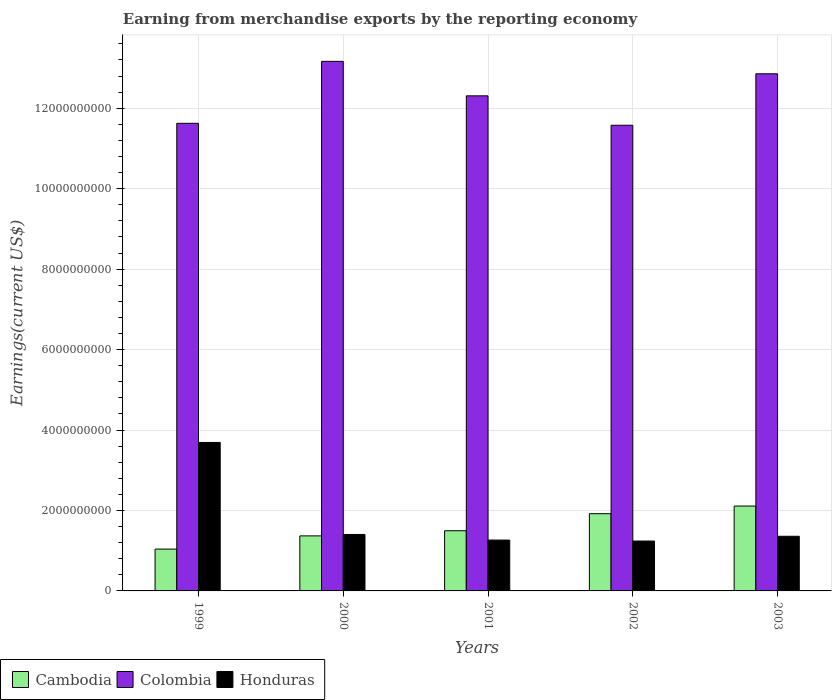Are the number of bars per tick equal to the number of legend labels?
Keep it short and to the point. Yes. How many bars are there on the 5th tick from the left?
Your answer should be very brief. 3. What is the label of the 1st group of bars from the left?
Your response must be concise. 1999. What is the amount earned from merchandise exports in Cambodia in 2001?
Offer a very short reply. 1.50e+09. Across all years, what is the maximum amount earned from merchandise exports in Colombia?
Make the answer very short. 1.32e+1. Across all years, what is the minimum amount earned from merchandise exports in Colombia?
Offer a very short reply. 1.16e+1. In which year was the amount earned from merchandise exports in Colombia maximum?
Offer a terse response. 2000. In which year was the amount earned from merchandise exports in Honduras minimum?
Ensure brevity in your answer.  2002. What is the total amount earned from merchandise exports in Honduras in the graph?
Give a very brief answer. 8.96e+09. What is the difference between the amount earned from merchandise exports in Colombia in 2000 and that in 2002?
Keep it short and to the point. 1.59e+09. What is the difference between the amount earned from merchandise exports in Colombia in 2000 and the amount earned from merchandise exports in Cambodia in 2001?
Offer a terse response. 1.17e+1. What is the average amount earned from merchandise exports in Cambodia per year?
Keep it short and to the point. 1.59e+09. In the year 2000, what is the difference between the amount earned from merchandise exports in Cambodia and amount earned from merchandise exports in Honduras?
Provide a short and direct response. -3.54e+07. What is the ratio of the amount earned from merchandise exports in Colombia in 2002 to that in 2003?
Provide a succinct answer. 0.9. Is the difference between the amount earned from merchandise exports in Cambodia in 2000 and 2003 greater than the difference between the amount earned from merchandise exports in Honduras in 2000 and 2003?
Ensure brevity in your answer.  No. What is the difference between the highest and the second highest amount earned from merchandise exports in Cambodia?
Provide a succinct answer. 1.90e+08. What is the difference between the highest and the lowest amount earned from merchandise exports in Honduras?
Give a very brief answer. 2.45e+09. What does the 3rd bar from the left in 2003 represents?
Your answer should be very brief. Honduras. What does the 1st bar from the right in 1999 represents?
Your answer should be compact. Honduras. Is it the case that in every year, the sum of the amount earned from merchandise exports in Colombia and amount earned from merchandise exports in Honduras is greater than the amount earned from merchandise exports in Cambodia?
Your response must be concise. Yes. Are all the bars in the graph horizontal?
Make the answer very short. No. What is the difference between two consecutive major ticks on the Y-axis?
Your response must be concise. 2.00e+09. Does the graph contain any zero values?
Ensure brevity in your answer.  No. What is the title of the graph?
Offer a terse response. Earning from merchandise exports by the reporting economy. Does "Sub-Saharan Africa (all income levels)" appear as one of the legend labels in the graph?
Your response must be concise. No. What is the label or title of the Y-axis?
Provide a short and direct response. Earnings(current US$). What is the Earnings(current US$) of Cambodia in 1999?
Your answer should be compact. 1.04e+09. What is the Earnings(current US$) of Colombia in 1999?
Make the answer very short. 1.16e+1. What is the Earnings(current US$) in Honduras in 1999?
Provide a succinct answer. 3.69e+09. What is the Earnings(current US$) of Cambodia in 2000?
Your response must be concise. 1.37e+09. What is the Earnings(current US$) of Colombia in 2000?
Make the answer very short. 1.32e+1. What is the Earnings(current US$) in Honduras in 2000?
Ensure brevity in your answer.  1.40e+09. What is the Earnings(current US$) of Cambodia in 2001?
Keep it short and to the point. 1.50e+09. What is the Earnings(current US$) in Colombia in 2001?
Your answer should be very brief. 1.23e+1. What is the Earnings(current US$) in Honduras in 2001?
Your answer should be very brief. 1.26e+09. What is the Earnings(current US$) of Cambodia in 2002?
Offer a very short reply. 1.92e+09. What is the Earnings(current US$) of Colombia in 2002?
Your response must be concise. 1.16e+1. What is the Earnings(current US$) in Honduras in 2002?
Your response must be concise. 1.24e+09. What is the Earnings(current US$) in Cambodia in 2003?
Your answer should be very brief. 2.11e+09. What is the Earnings(current US$) in Colombia in 2003?
Ensure brevity in your answer.  1.29e+1. What is the Earnings(current US$) of Honduras in 2003?
Offer a very short reply. 1.36e+09. Across all years, what is the maximum Earnings(current US$) of Cambodia?
Your answer should be very brief. 2.11e+09. Across all years, what is the maximum Earnings(current US$) of Colombia?
Your answer should be very brief. 1.32e+1. Across all years, what is the maximum Earnings(current US$) of Honduras?
Keep it short and to the point. 3.69e+09. Across all years, what is the minimum Earnings(current US$) in Cambodia?
Ensure brevity in your answer.  1.04e+09. Across all years, what is the minimum Earnings(current US$) in Colombia?
Provide a succinct answer. 1.16e+1. Across all years, what is the minimum Earnings(current US$) in Honduras?
Keep it short and to the point. 1.24e+09. What is the total Earnings(current US$) in Cambodia in the graph?
Provide a succinct answer. 7.93e+09. What is the total Earnings(current US$) in Colombia in the graph?
Your answer should be very brief. 6.15e+1. What is the total Earnings(current US$) of Honduras in the graph?
Give a very brief answer. 8.96e+09. What is the difference between the Earnings(current US$) of Cambodia in 1999 and that in 2000?
Offer a very short reply. -3.28e+08. What is the difference between the Earnings(current US$) of Colombia in 1999 and that in 2000?
Ensure brevity in your answer.  -1.54e+09. What is the difference between the Earnings(current US$) in Honduras in 1999 and that in 2000?
Provide a succinct answer. 2.29e+09. What is the difference between the Earnings(current US$) of Cambodia in 1999 and that in 2001?
Your response must be concise. -4.56e+08. What is the difference between the Earnings(current US$) of Colombia in 1999 and that in 2001?
Your answer should be compact. -6.83e+08. What is the difference between the Earnings(current US$) in Honduras in 1999 and that in 2001?
Offer a terse response. 2.43e+09. What is the difference between the Earnings(current US$) in Cambodia in 1999 and that in 2002?
Ensure brevity in your answer.  -8.79e+08. What is the difference between the Earnings(current US$) of Colombia in 1999 and that in 2002?
Provide a short and direct response. 4.76e+07. What is the difference between the Earnings(current US$) of Honduras in 1999 and that in 2002?
Make the answer very short. 2.45e+09. What is the difference between the Earnings(current US$) in Cambodia in 1999 and that in 2003?
Ensure brevity in your answer.  -1.07e+09. What is the difference between the Earnings(current US$) of Colombia in 1999 and that in 2003?
Provide a succinct answer. -1.23e+09. What is the difference between the Earnings(current US$) of Honduras in 1999 and that in 2003?
Your answer should be very brief. 2.33e+09. What is the difference between the Earnings(current US$) of Cambodia in 2000 and that in 2001?
Provide a succinct answer. -1.28e+08. What is the difference between the Earnings(current US$) in Colombia in 2000 and that in 2001?
Keep it short and to the point. 8.57e+08. What is the difference between the Earnings(current US$) of Honduras in 2000 and that in 2001?
Offer a very short reply. 1.40e+08. What is the difference between the Earnings(current US$) of Cambodia in 2000 and that in 2002?
Your answer should be compact. -5.51e+08. What is the difference between the Earnings(current US$) of Colombia in 2000 and that in 2002?
Offer a very short reply. 1.59e+09. What is the difference between the Earnings(current US$) in Honduras in 2000 and that in 2002?
Your response must be concise. 1.64e+08. What is the difference between the Earnings(current US$) in Cambodia in 2000 and that in 2003?
Your answer should be very brief. -7.42e+08. What is the difference between the Earnings(current US$) in Colombia in 2000 and that in 2003?
Your answer should be very brief. 3.09e+08. What is the difference between the Earnings(current US$) in Honduras in 2000 and that in 2003?
Provide a short and direct response. 4.49e+07. What is the difference between the Earnings(current US$) of Cambodia in 2001 and that in 2002?
Ensure brevity in your answer.  -4.23e+08. What is the difference between the Earnings(current US$) of Colombia in 2001 and that in 2002?
Your response must be concise. 7.31e+08. What is the difference between the Earnings(current US$) in Honduras in 2001 and that in 2002?
Your answer should be compact. 2.41e+07. What is the difference between the Earnings(current US$) of Cambodia in 2001 and that in 2003?
Provide a short and direct response. -6.14e+08. What is the difference between the Earnings(current US$) in Colombia in 2001 and that in 2003?
Provide a short and direct response. -5.48e+08. What is the difference between the Earnings(current US$) in Honduras in 2001 and that in 2003?
Ensure brevity in your answer.  -9.46e+07. What is the difference between the Earnings(current US$) in Cambodia in 2002 and that in 2003?
Your answer should be compact. -1.90e+08. What is the difference between the Earnings(current US$) of Colombia in 2002 and that in 2003?
Your response must be concise. -1.28e+09. What is the difference between the Earnings(current US$) of Honduras in 2002 and that in 2003?
Offer a very short reply. -1.19e+08. What is the difference between the Earnings(current US$) of Cambodia in 1999 and the Earnings(current US$) of Colombia in 2000?
Ensure brevity in your answer.  -1.21e+1. What is the difference between the Earnings(current US$) of Cambodia in 1999 and the Earnings(current US$) of Honduras in 2000?
Make the answer very short. -3.63e+08. What is the difference between the Earnings(current US$) of Colombia in 1999 and the Earnings(current US$) of Honduras in 2000?
Offer a terse response. 1.02e+1. What is the difference between the Earnings(current US$) in Cambodia in 1999 and the Earnings(current US$) in Colombia in 2001?
Your answer should be very brief. -1.13e+1. What is the difference between the Earnings(current US$) in Cambodia in 1999 and the Earnings(current US$) in Honduras in 2001?
Make the answer very short. -2.24e+08. What is the difference between the Earnings(current US$) of Colombia in 1999 and the Earnings(current US$) of Honduras in 2001?
Offer a very short reply. 1.04e+1. What is the difference between the Earnings(current US$) in Cambodia in 1999 and the Earnings(current US$) in Colombia in 2002?
Keep it short and to the point. -1.05e+1. What is the difference between the Earnings(current US$) of Cambodia in 1999 and the Earnings(current US$) of Honduras in 2002?
Keep it short and to the point. -2.00e+08. What is the difference between the Earnings(current US$) in Colombia in 1999 and the Earnings(current US$) in Honduras in 2002?
Your response must be concise. 1.04e+1. What is the difference between the Earnings(current US$) in Cambodia in 1999 and the Earnings(current US$) in Colombia in 2003?
Your answer should be compact. -1.18e+1. What is the difference between the Earnings(current US$) in Cambodia in 1999 and the Earnings(current US$) in Honduras in 2003?
Provide a succinct answer. -3.19e+08. What is the difference between the Earnings(current US$) in Colombia in 1999 and the Earnings(current US$) in Honduras in 2003?
Give a very brief answer. 1.03e+1. What is the difference between the Earnings(current US$) in Cambodia in 2000 and the Earnings(current US$) in Colombia in 2001?
Make the answer very short. -1.09e+1. What is the difference between the Earnings(current US$) of Cambodia in 2000 and the Earnings(current US$) of Honduras in 2001?
Provide a short and direct response. 1.04e+08. What is the difference between the Earnings(current US$) in Colombia in 2000 and the Earnings(current US$) in Honduras in 2001?
Give a very brief answer. 1.19e+1. What is the difference between the Earnings(current US$) in Cambodia in 2000 and the Earnings(current US$) in Colombia in 2002?
Ensure brevity in your answer.  -1.02e+1. What is the difference between the Earnings(current US$) of Cambodia in 2000 and the Earnings(current US$) of Honduras in 2002?
Offer a very short reply. 1.28e+08. What is the difference between the Earnings(current US$) of Colombia in 2000 and the Earnings(current US$) of Honduras in 2002?
Offer a terse response. 1.19e+1. What is the difference between the Earnings(current US$) in Cambodia in 2000 and the Earnings(current US$) in Colombia in 2003?
Your answer should be compact. -1.15e+1. What is the difference between the Earnings(current US$) in Cambodia in 2000 and the Earnings(current US$) in Honduras in 2003?
Provide a succinct answer. 9.48e+06. What is the difference between the Earnings(current US$) in Colombia in 2000 and the Earnings(current US$) in Honduras in 2003?
Give a very brief answer. 1.18e+1. What is the difference between the Earnings(current US$) in Cambodia in 2001 and the Earnings(current US$) in Colombia in 2002?
Make the answer very short. -1.01e+1. What is the difference between the Earnings(current US$) in Cambodia in 2001 and the Earnings(current US$) in Honduras in 2002?
Ensure brevity in your answer.  2.56e+08. What is the difference between the Earnings(current US$) in Colombia in 2001 and the Earnings(current US$) in Honduras in 2002?
Make the answer very short. 1.11e+1. What is the difference between the Earnings(current US$) of Cambodia in 2001 and the Earnings(current US$) of Colombia in 2003?
Provide a short and direct response. -1.14e+1. What is the difference between the Earnings(current US$) of Cambodia in 2001 and the Earnings(current US$) of Honduras in 2003?
Provide a succinct answer. 1.38e+08. What is the difference between the Earnings(current US$) in Colombia in 2001 and the Earnings(current US$) in Honduras in 2003?
Make the answer very short. 1.09e+1. What is the difference between the Earnings(current US$) in Cambodia in 2002 and the Earnings(current US$) in Colombia in 2003?
Offer a very short reply. -1.09e+1. What is the difference between the Earnings(current US$) in Cambodia in 2002 and the Earnings(current US$) in Honduras in 2003?
Provide a succinct answer. 5.61e+08. What is the difference between the Earnings(current US$) of Colombia in 2002 and the Earnings(current US$) of Honduras in 2003?
Your response must be concise. 1.02e+1. What is the average Earnings(current US$) in Cambodia per year?
Provide a succinct answer. 1.59e+09. What is the average Earnings(current US$) in Colombia per year?
Your response must be concise. 1.23e+1. What is the average Earnings(current US$) in Honduras per year?
Offer a terse response. 1.79e+09. In the year 1999, what is the difference between the Earnings(current US$) in Cambodia and Earnings(current US$) in Colombia?
Give a very brief answer. -1.06e+1. In the year 1999, what is the difference between the Earnings(current US$) of Cambodia and Earnings(current US$) of Honduras?
Offer a terse response. -2.65e+09. In the year 1999, what is the difference between the Earnings(current US$) of Colombia and Earnings(current US$) of Honduras?
Offer a terse response. 7.93e+09. In the year 2000, what is the difference between the Earnings(current US$) of Cambodia and Earnings(current US$) of Colombia?
Make the answer very short. -1.18e+1. In the year 2000, what is the difference between the Earnings(current US$) in Cambodia and Earnings(current US$) in Honduras?
Give a very brief answer. -3.54e+07. In the year 2000, what is the difference between the Earnings(current US$) of Colombia and Earnings(current US$) of Honduras?
Make the answer very short. 1.18e+1. In the year 2001, what is the difference between the Earnings(current US$) in Cambodia and Earnings(current US$) in Colombia?
Offer a very short reply. -1.08e+1. In the year 2001, what is the difference between the Earnings(current US$) of Cambodia and Earnings(current US$) of Honduras?
Keep it short and to the point. 2.32e+08. In the year 2001, what is the difference between the Earnings(current US$) in Colombia and Earnings(current US$) in Honduras?
Your answer should be compact. 1.10e+1. In the year 2002, what is the difference between the Earnings(current US$) in Cambodia and Earnings(current US$) in Colombia?
Offer a very short reply. -9.66e+09. In the year 2002, what is the difference between the Earnings(current US$) in Cambodia and Earnings(current US$) in Honduras?
Make the answer very short. 6.80e+08. In the year 2002, what is the difference between the Earnings(current US$) of Colombia and Earnings(current US$) of Honduras?
Offer a terse response. 1.03e+1. In the year 2003, what is the difference between the Earnings(current US$) of Cambodia and Earnings(current US$) of Colombia?
Your answer should be very brief. -1.07e+1. In the year 2003, what is the difference between the Earnings(current US$) of Cambodia and Earnings(current US$) of Honduras?
Your answer should be compact. 7.51e+08. In the year 2003, what is the difference between the Earnings(current US$) of Colombia and Earnings(current US$) of Honduras?
Keep it short and to the point. 1.15e+1. What is the ratio of the Earnings(current US$) of Cambodia in 1999 to that in 2000?
Keep it short and to the point. 0.76. What is the ratio of the Earnings(current US$) in Colombia in 1999 to that in 2000?
Make the answer very short. 0.88. What is the ratio of the Earnings(current US$) of Honduras in 1999 to that in 2000?
Provide a short and direct response. 2.63. What is the ratio of the Earnings(current US$) of Cambodia in 1999 to that in 2001?
Offer a very short reply. 0.7. What is the ratio of the Earnings(current US$) in Colombia in 1999 to that in 2001?
Your answer should be very brief. 0.94. What is the ratio of the Earnings(current US$) of Honduras in 1999 to that in 2001?
Make the answer very short. 2.92. What is the ratio of the Earnings(current US$) of Cambodia in 1999 to that in 2002?
Your response must be concise. 0.54. What is the ratio of the Earnings(current US$) of Honduras in 1999 to that in 2002?
Your answer should be very brief. 2.98. What is the ratio of the Earnings(current US$) in Cambodia in 1999 to that in 2003?
Your response must be concise. 0.49. What is the ratio of the Earnings(current US$) in Colombia in 1999 to that in 2003?
Keep it short and to the point. 0.9. What is the ratio of the Earnings(current US$) of Honduras in 1999 to that in 2003?
Offer a terse response. 2.72. What is the ratio of the Earnings(current US$) in Cambodia in 2000 to that in 2001?
Provide a short and direct response. 0.91. What is the ratio of the Earnings(current US$) in Colombia in 2000 to that in 2001?
Provide a succinct answer. 1.07. What is the ratio of the Earnings(current US$) of Honduras in 2000 to that in 2001?
Offer a terse response. 1.11. What is the ratio of the Earnings(current US$) in Cambodia in 2000 to that in 2002?
Provide a short and direct response. 0.71. What is the ratio of the Earnings(current US$) of Colombia in 2000 to that in 2002?
Provide a short and direct response. 1.14. What is the ratio of the Earnings(current US$) of Honduras in 2000 to that in 2002?
Offer a terse response. 1.13. What is the ratio of the Earnings(current US$) in Cambodia in 2000 to that in 2003?
Give a very brief answer. 0.65. What is the ratio of the Earnings(current US$) in Colombia in 2000 to that in 2003?
Make the answer very short. 1.02. What is the ratio of the Earnings(current US$) in Honduras in 2000 to that in 2003?
Keep it short and to the point. 1.03. What is the ratio of the Earnings(current US$) of Cambodia in 2001 to that in 2002?
Your response must be concise. 0.78. What is the ratio of the Earnings(current US$) of Colombia in 2001 to that in 2002?
Your response must be concise. 1.06. What is the ratio of the Earnings(current US$) of Honduras in 2001 to that in 2002?
Give a very brief answer. 1.02. What is the ratio of the Earnings(current US$) of Cambodia in 2001 to that in 2003?
Provide a short and direct response. 0.71. What is the ratio of the Earnings(current US$) of Colombia in 2001 to that in 2003?
Your answer should be compact. 0.96. What is the ratio of the Earnings(current US$) of Honduras in 2001 to that in 2003?
Ensure brevity in your answer.  0.93. What is the ratio of the Earnings(current US$) of Cambodia in 2002 to that in 2003?
Provide a short and direct response. 0.91. What is the ratio of the Earnings(current US$) in Colombia in 2002 to that in 2003?
Offer a terse response. 0.9. What is the ratio of the Earnings(current US$) of Honduras in 2002 to that in 2003?
Provide a short and direct response. 0.91. What is the difference between the highest and the second highest Earnings(current US$) of Cambodia?
Your response must be concise. 1.90e+08. What is the difference between the highest and the second highest Earnings(current US$) in Colombia?
Keep it short and to the point. 3.09e+08. What is the difference between the highest and the second highest Earnings(current US$) of Honduras?
Offer a very short reply. 2.29e+09. What is the difference between the highest and the lowest Earnings(current US$) in Cambodia?
Your response must be concise. 1.07e+09. What is the difference between the highest and the lowest Earnings(current US$) in Colombia?
Offer a very short reply. 1.59e+09. What is the difference between the highest and the lowest Earnings(current US$) in Honduras?
Give a very brief answer. 2.45e+09. 